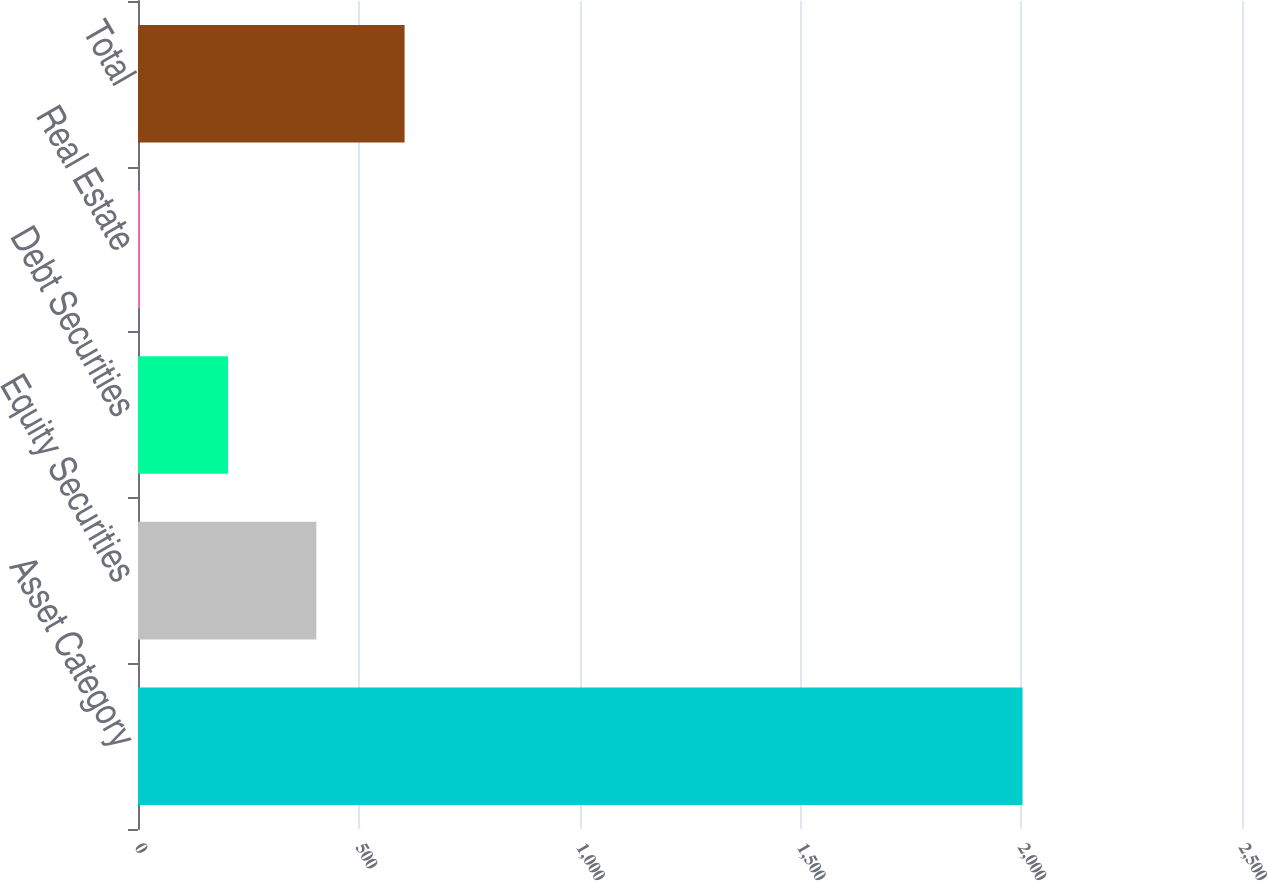<chart> <loc_0><loc_0><loc_500><loc_500><bar_chart><fcel>Asset Category<fcel>Equity Securities<fcel>Debt Securities<fcel>Real Estate<fcel>Total<nl><fcel>2003<fcel>403.8<fcel>203.9<fcel>4<fcel>603.7<nl></chart> 